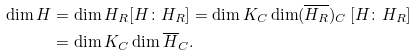Convert formula to latex. <formula><loc_0><loc_0><loc_500><loc_500>\dim H & = \dim H _ { R } [ H \colon H _ { R } ] = \dim K _ { C } \dim ( \overline { H _ { R } } ) _ { C } \, [ H \colon H _ { R } ] \\ & = \dim K _ { C } \dim \overline { H } _ { C } .</formula> 